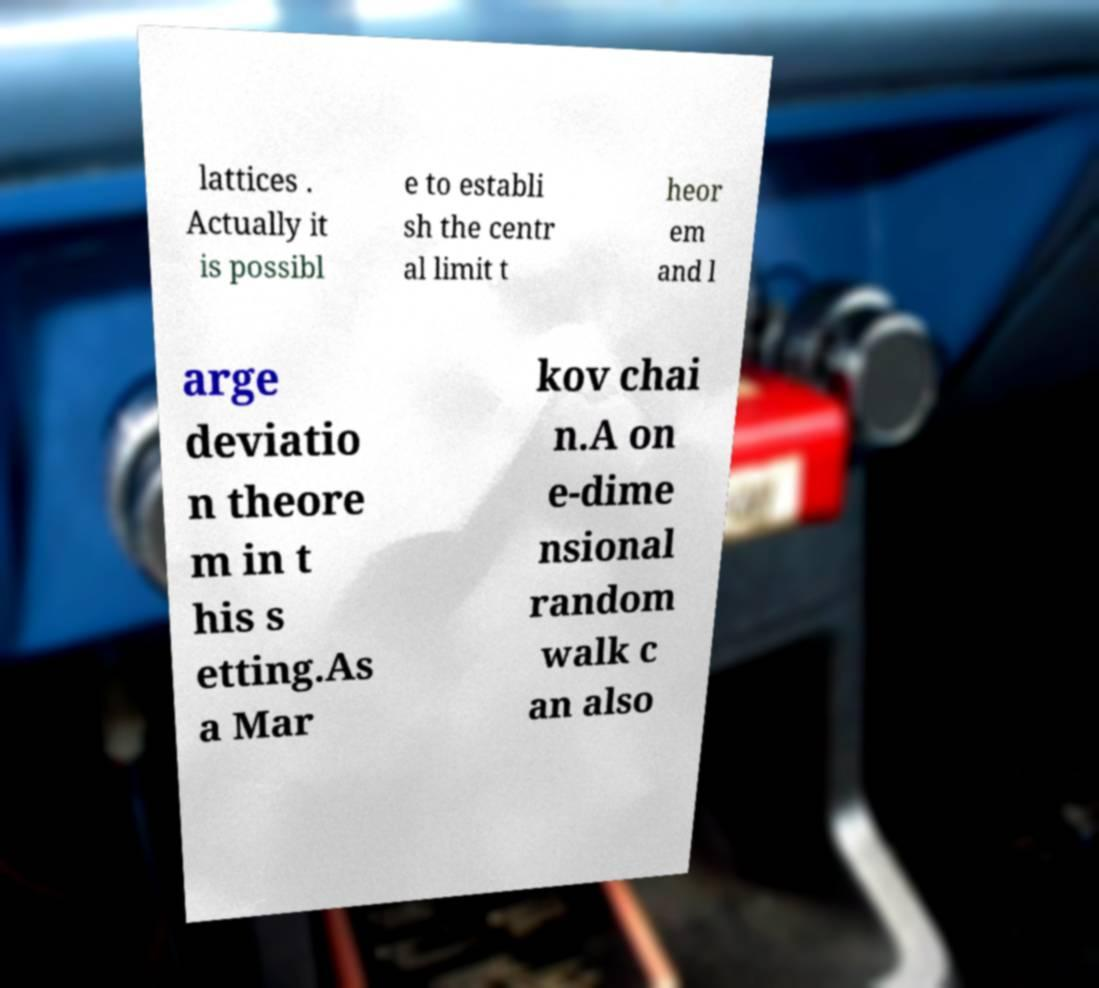For documentation purposes, I need the text within this image transcribed. Could you provide that? lattices . Actually it is possibl e to establi sh the centr al limit t heor em and l arge deviatio n theore m in t his s etting.As a Mar kov chai n.A on e-dime nsional random walk c an also 